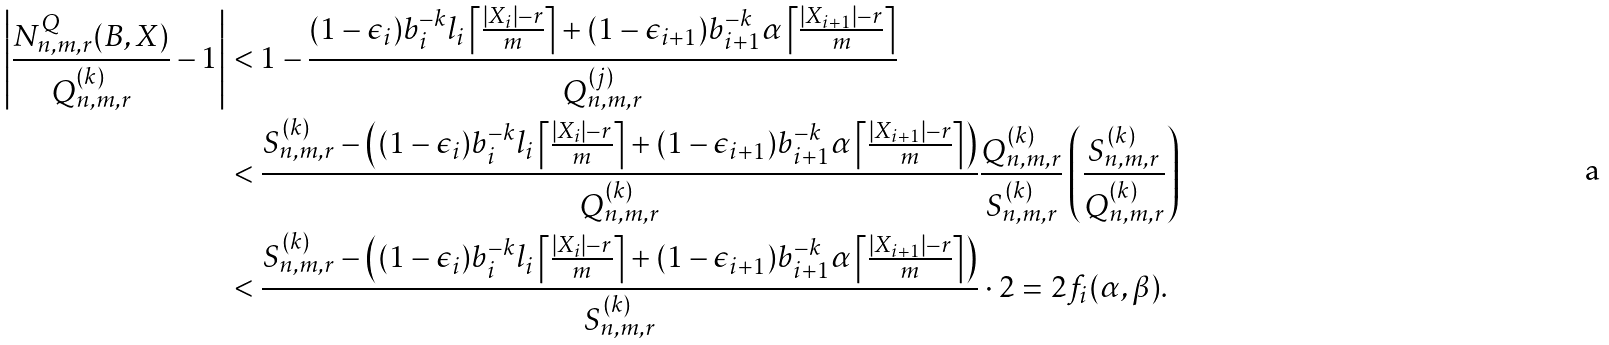Convert formula to latex. <formula><loc_0><loc_0><loc_500><loc_500>\left | \frac { N _ { n , m , r } ^ { Q } ( B , X ) } { Q _ { n , m , r } ^ { ( k ) } } - 1 \right | & < 1 - \frac { ( 1 - \epsilon _ { i } ) b _ { i } ^ { - k } l _ { i } \left \lceil \frac { | X _ { i } | - r } { m } \right \rceil + ( 1 - \epsilon _ { i + 1 } ) b _ { i + 1 } ^ { - k } \alpha \left \lceil \frac { | X _ { i + 1 } | - r } { m } \right \rceil } { Q _ { n , m , r } ^ { ( j ) } } \\ & < \frac { { S } _ { n , m , r } ^ { ( k ) } - \left ( ( 1 - \epsilon _ { i } ) b _ { i } ^ { - k } l _ { i } \left \lceil \frac { | X _ { i } | - r } { m } \right \rceil + ( 1 - \epsilon _ { i + 1 } ) b _ { i + 1 } ^ { - k } \alpha \left \lceil \frac { | X _ { i + 1 } | - r } { m } \right \rceil \right ) } { Q _ { n , m , r } ^ { ( k ) } } \frac { Q _ { n , m , r } ^ { ( k ) } } { { S } _ { n , m , r } ^ { ( k ) } } \left ( \frac { { S } _ { n , m , r } ^ { ( k ) } } { Q _ { n , m , r } ^ { ( k ) } } \right ) \\ & < \frac { { S } _ { n , m , r } ^ { ( k ) } - \left ( ( 1 - \epsilon _ { i } ) b _ { i } ^ { - k } l _ { i } \left \lceil \frac { | X _ { i } | - r } { m } \right \rceil + ( 1 - \epsilon _ { i + 1 } ) b _ { i + 1 } ^ { - k } \alpha \left \lceil \frac { | X _ { i + 1 } | - r } { m } \right \rceil \right ) } { { S } _ { n , m , r } ^ { ( k ) } } \cdot 2 = 2 f _ { i } ( \alpha , \beta ) .</formula> 